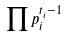<formula> <loc_0><loc_0><loc_500><loc_500>\prod p _ { i } ^ { t _ { i } - 1 }</formula> 